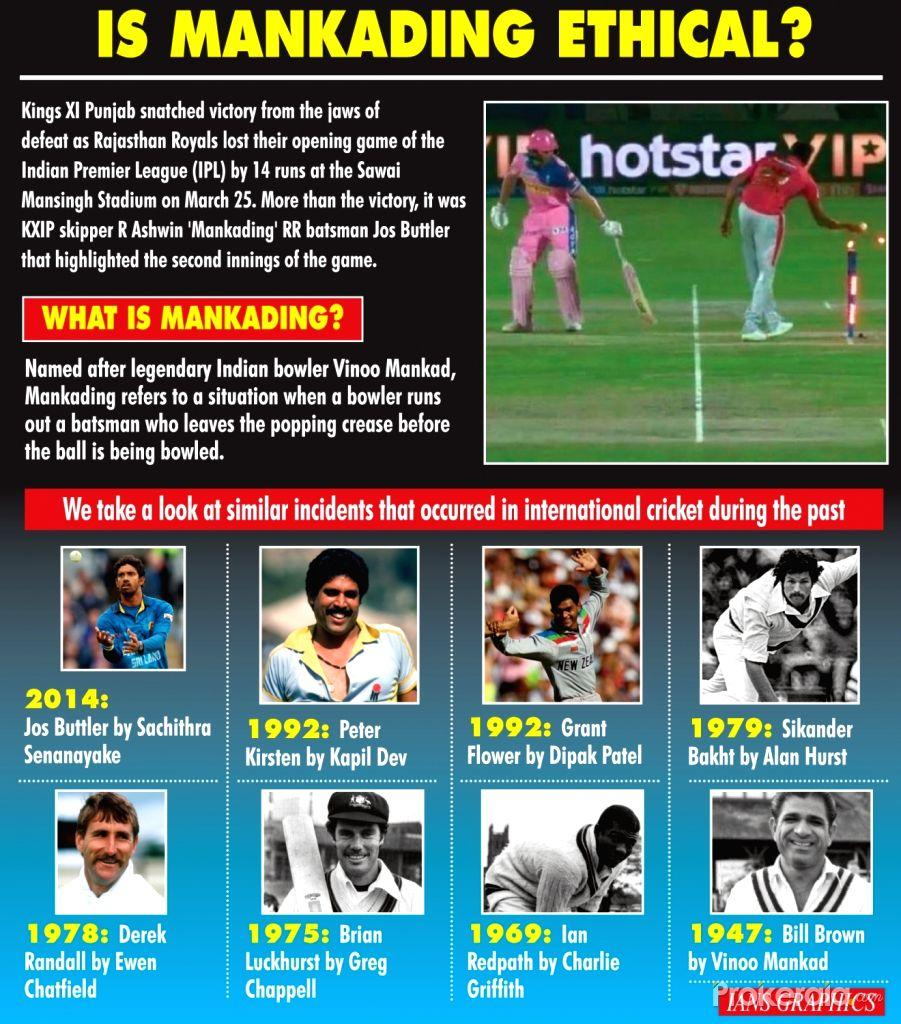Draw attention to some important aspects in this diagram. There have been a total of 9 Mankading incidents mentioned in this infographic. 